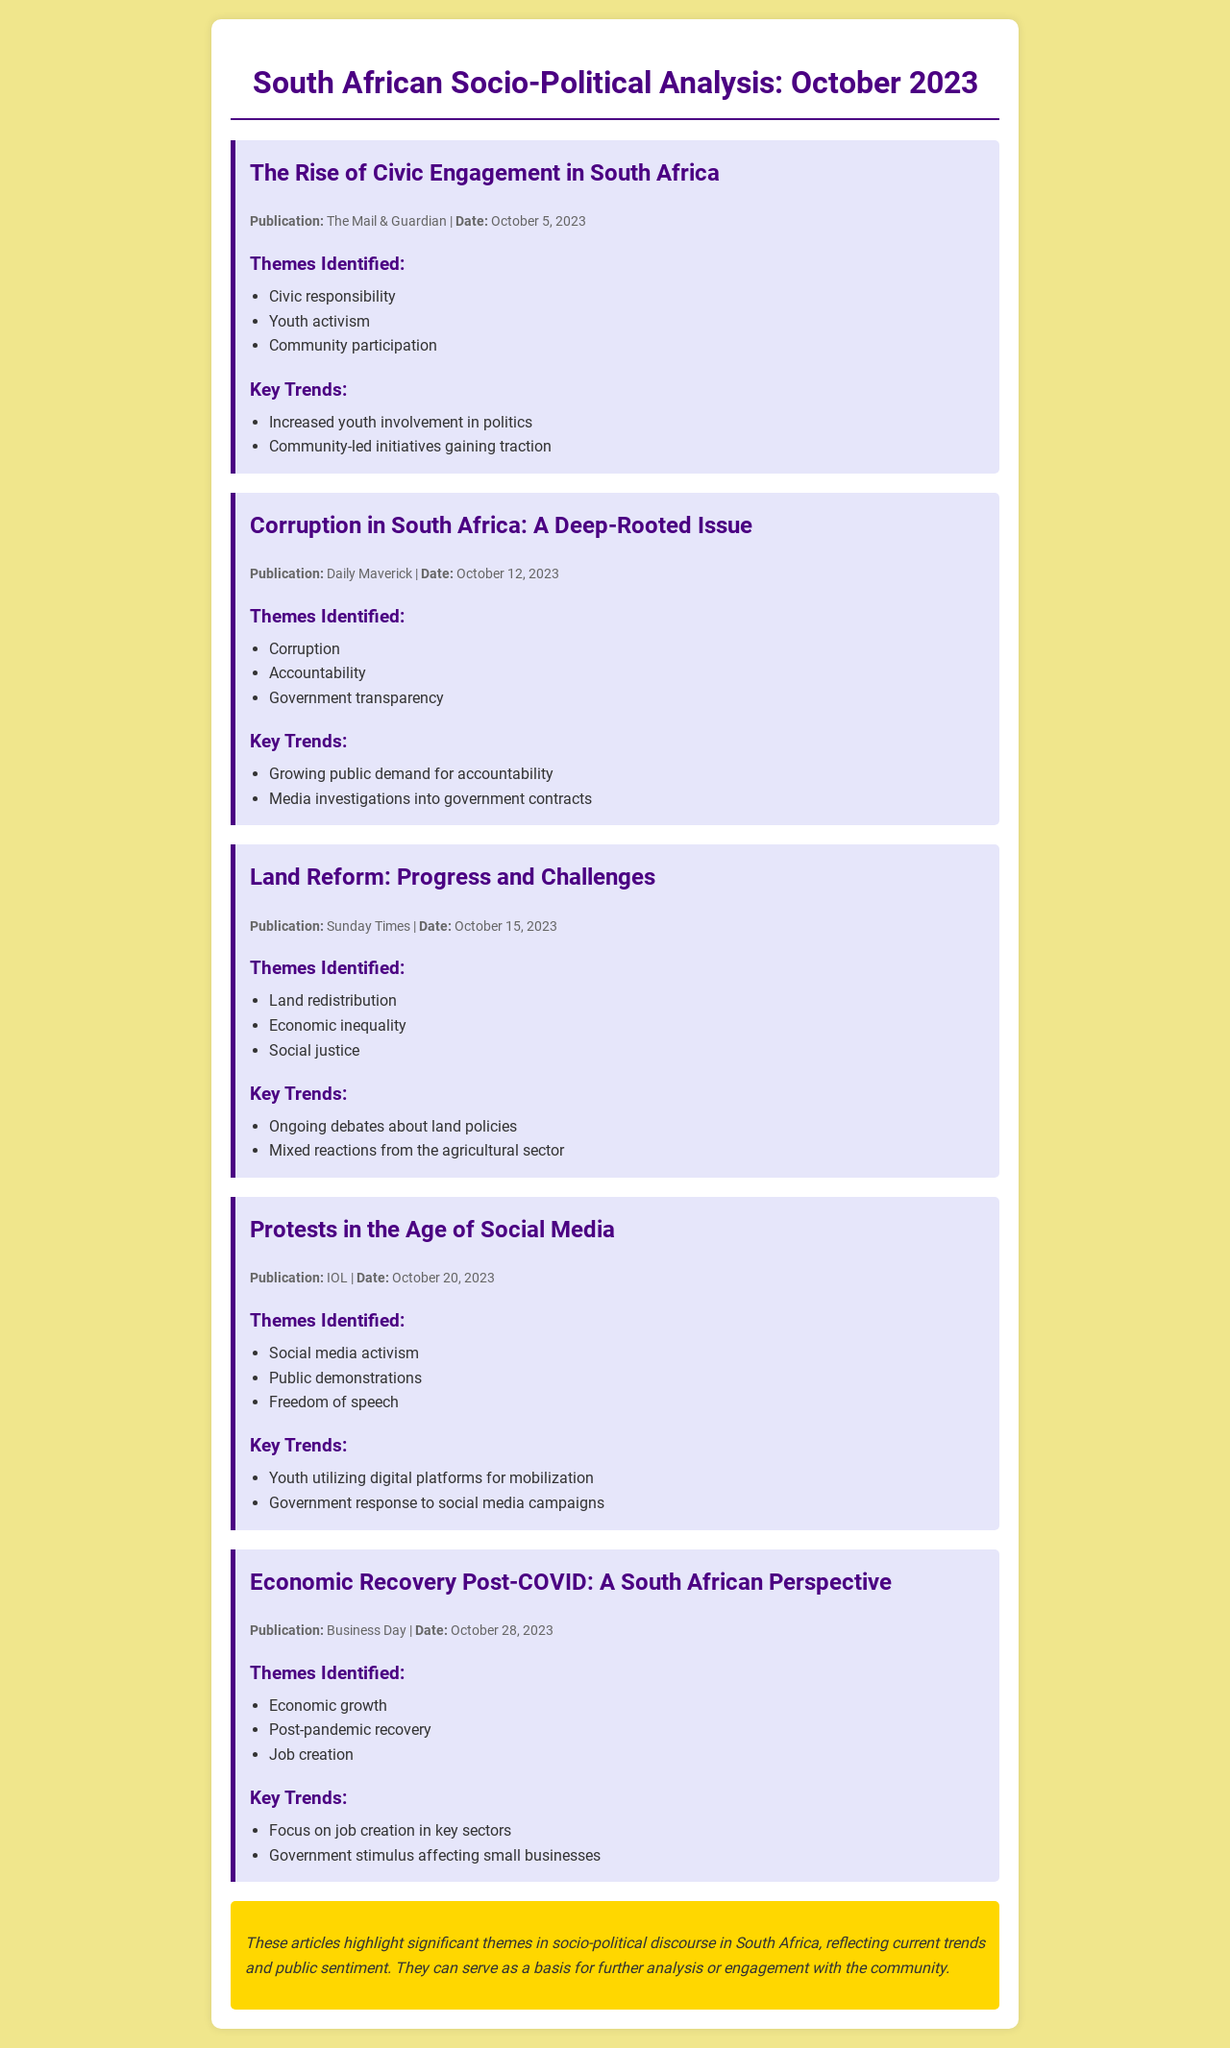What is the title of the first article? The title is mentioned prominently at the beginning of the article section.
Answer: The Rise of Civic Engagement in South Africa Which publication featured the article on corruption? The publication name is listed under the article's publication details.
Answer: Daily Maverick What date was the article about land reform published? The publication date is specified right after the publication name.
Answer: October 15, 2023 List one of the themes identified in the article on economic recovery. Themes are listed under each article to highlight key discussion points.
Answer: Economic growth What is a key trend identified in the protests article? Key trends are outlined in a section dedicated to summarizing the article's main arguments.
Answer: Youth utilizing digital platforms for mobilization How many articles are included in the document? The number of articles can be counted by reviewing the individual article sections.
Answer: Five What is the main theme discussed in the article from The Mail & Guardian? Themes are identified in a dedicated section below the article title.
Answer: Civic responsibility Who published the last article in the schedule? The publication name is mentioned in the article details for identification.
Answer: Business Day 